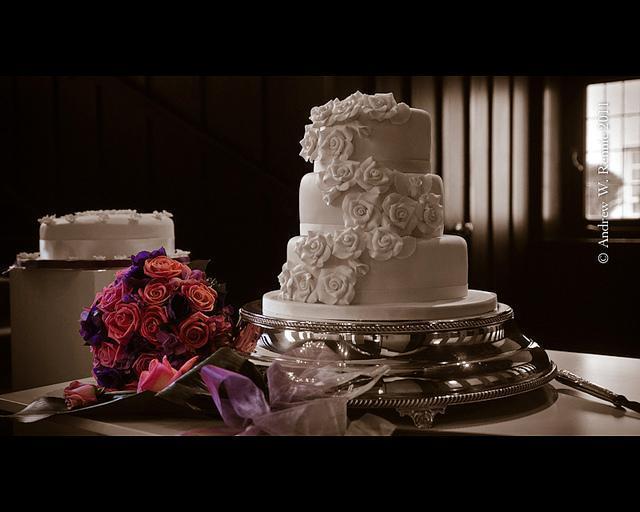How many tiers are in this cake?
Give a very brief answer. 3. How many tiers does the cake have?
Give a very brief answer. 3. How many cakes are there?
Give a very brief answer. 2. 